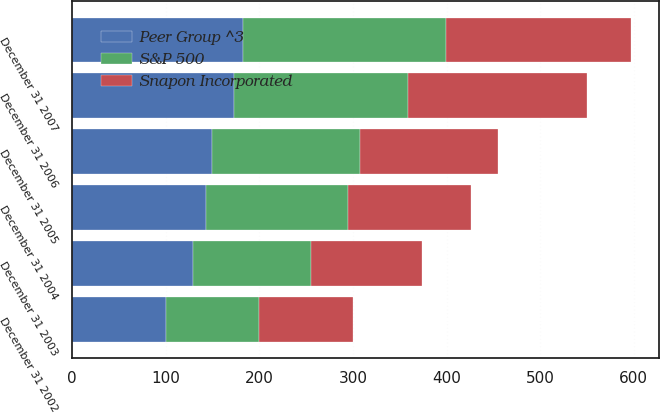Convert chart. <chart><loc_0><loc_0><loc_500><loc_500><stacked_bar_chart><ecel><fcel>December 31 2002<fcel>December 31 2003<fcel>December 31 2004<fcel>December 31 2005<fcel>December 31 2006<fcel>December 31 2007<nl><fcel>Snapon Incorporated<fcel>100<fcel>118.8<fcel>130.66<fcel>146.97<fcel>191.27<fcel>198.05<nl><fcel>S&P 500<fcel>100<fcel>126.16<fcel>152.42<fcel>157.97<fcel>185.1<fcel>216.19<nl><fcel>Peer Group ^3<fcel>100<fcel>128.68<fcel>142.69<fcel>149.7<fcel>173.34<fcel>182.87<nl></chart> 